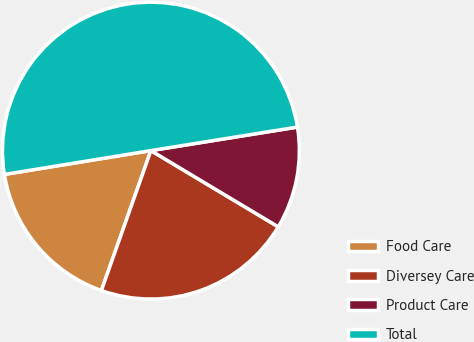Convert chart to OTSL. <chart><loc_0><loc_0><loc_500><loc_500><pie_chart><fcel>Food Care<fcel>Diversey Care<fcel>Product Care<fcel>Total<nl><fcel>17.02%<fcel>21.83%<fcel>11.12%<fcel>50.03%<nl></chart> 